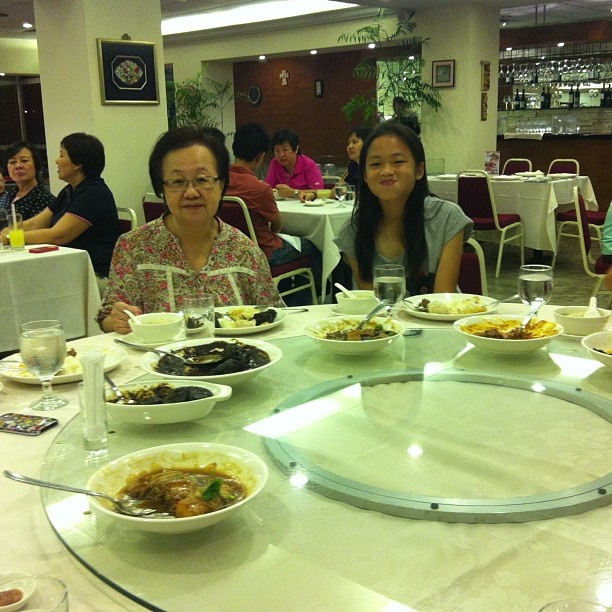Describe the objects in this image and their specific colors. I can see dining table in gray, khaki, olive, lightgreen, and lightyellow tones, people in gray, olive, and black tones, people in gray, black, olive, and darkgreen tones, bowl in gray, khaki, and olive tones, and potted plant in gray, black, darkgreen, and olive tones in this image. 